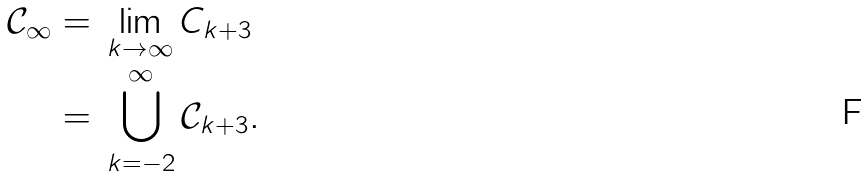<formula> <loc_0><loc_0><loc_500><loc_500>\mathcal { C } _ { \infty } & = \, \lim _ { k \to \infty } C _ { k + 3 } \\ & = \, \bigcup _ { k = - 2 } ^ { \infty } \mathcal { C } _ { k + 3 } . \\ &</formula> 